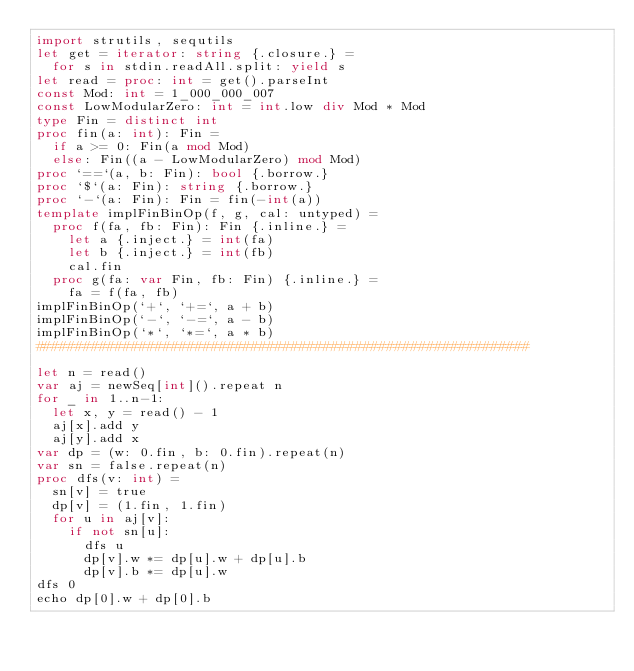<code> <loc_0><loc_0><loc_500><loc_500><_Nim_>import strutils, sequtils
let get = iterator: string {.closure.} =
  for s in stdin.readAll.split: yield s
let read = proc: int = get().parseInt
const Mod: int = 1_000_000_007
const LowModularZero: int = int.low div Mod * Mod
type Fin = distinct int
proc fin(a: int): Fin = 
  if a >= 0: Fin(a mod Mod)
  else: Fin((a - LowModularZero) mod Mod)
proc `==`(a, b: Fin): bool {.borrow.}
proc `$`(a: Fin): string {.borrow.}
proc `-`(a: Fin): Fin = fin(-int(a))  
template implFinBinOp(f, g, cal: untyped) =
  proc f(fa, fb: Fin): Fin {.inline.} =
    let a {.inject.} = int(fa)
    let b {.inject.} = int(fb)
    cal.fin
  proc g(fa: var Fin, fb: Fin) {.inline.} =
    fa = f(fa, fb)
implFinBinOp(`+`, `+=`, a + b)
implFinBinOp(`-`, `-=`, a - b)
implFinBinOp(`*`, `*=`, a * b)
##############################################################

let n = read()
var aj = newSeq[int]().repeat n
for _ in 1..n-1:
  let x, y = read() - 1
  aj[x].add y
  aj[y].add x
var dp = (w: 0.fin, b: 0.fin).repeat(n)
var sn = false.repeat(n)
proc dfs(v: int) =
  sn[v] = true
  dp[v] = (1.fin, 1.fin)
  for u in aj[v]:
    if not sn[u]:
      dfs u
      dp[v].w *= dp[u].w + dp[u].b
      dp[v].b *= dp[u].w
dfs 0
echo dp[0].w + dp[0].b
      </code> 